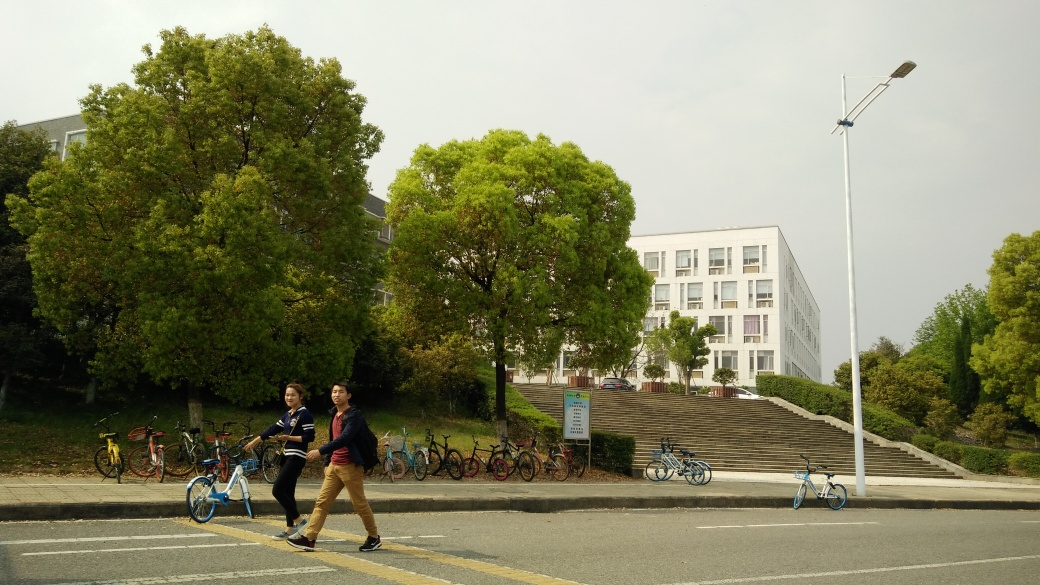Are the colors in the image accurate? Determining the accuracy of colors in an image requires an understanding of the context, lighting, and camera settings at the time of capture. From the image provided, it appears that the colors are represented with a good level of fidelity, though there might be some minor discrepancies due to the overcast sky which could make the colors seem slightly muted. Without the original scene for a direct comparison, precise accuracy cannot be definitively confirmed. 